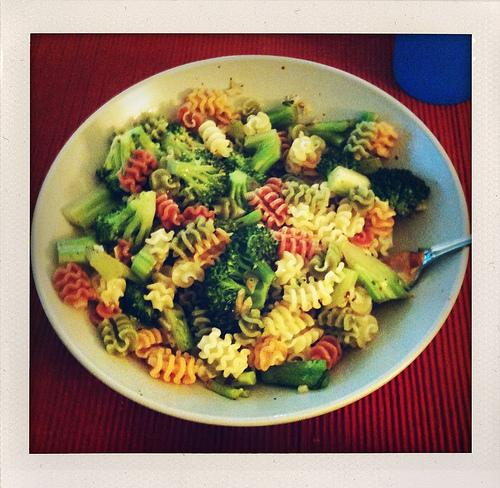What is in the bowl? pasta 